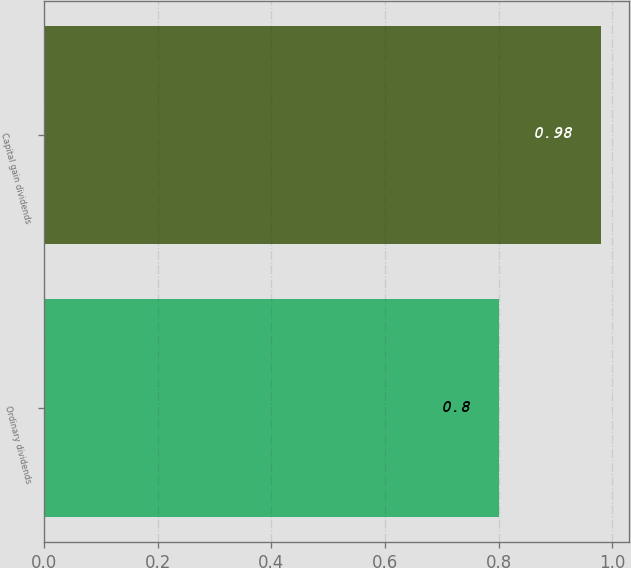Convert chart. <chart><loc_0><loc_0><loc_500><loc_500><bar_chart><fcel>Ordinary dividends<fcel>Capital gain dividends<nl><fcel>0.8<fcel>0.98<nl></chart> 